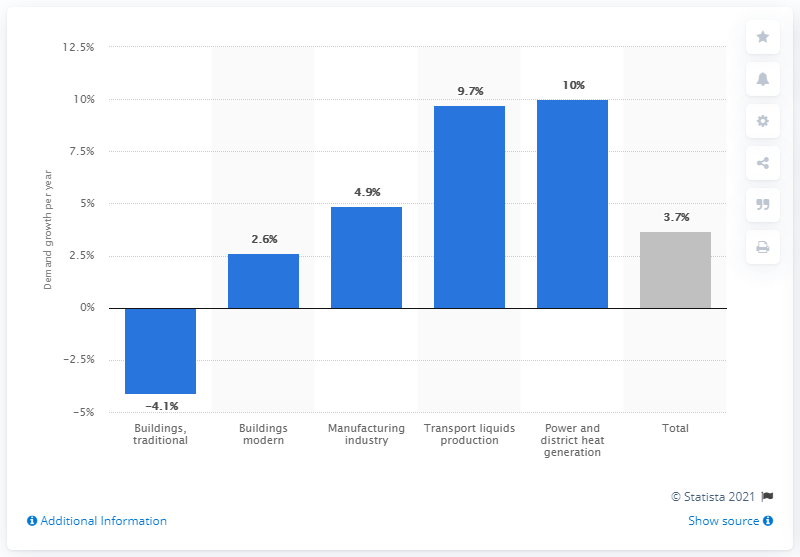List a handful of essential elements in this visual. The global biomass demand is expected to increase by a percentage of 10 during the forecast period. This information is based on research and analysis conducted by industry experts and market analysts. 